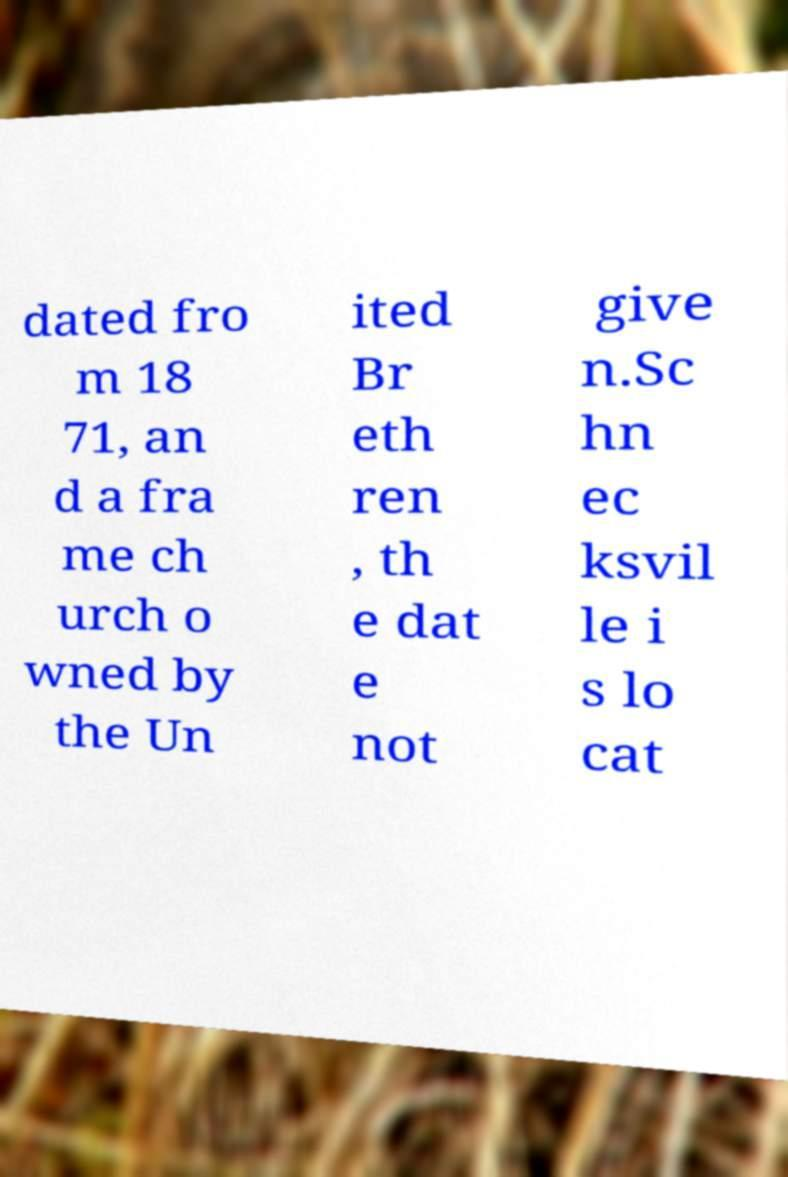There's text embedded in this image that I need extracted. Can you transcribe it verbatim? dated fro m 18 71, an d a fra me ch urch o wned by the Un ited Br eth ren , th e dat e not give n.Sc hn ec ksvil le i s lo cat 